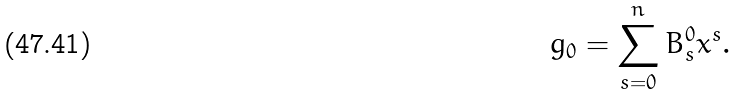Convert formula to latex. <formula><loc_0><loc_0><loc_500><loc_500>g _ { 0 } = \sum _ { s = 0 } ^ { n } B _ { s } ^ { 0 } x ^ { s } .</formula> 